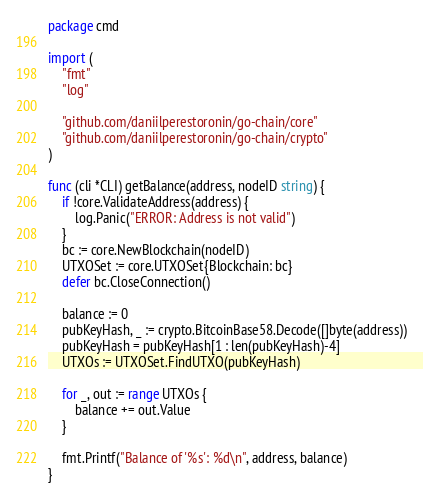Convert code to text. <code><loc_0><loc_0><loc_500><loc_500><_Go_>package cmd

import (
	"fmt"
	"log"

	"github.com/daniilperestoronin/go-chain/core"
	"github.com/daniilperestoronin/go-chain/crypto"
)

func (cli *CLI) getBalance(address, nodeID string) {
	if !core.ValidateAddress(address) {
		log.Panic("ERROR: Address is not valid")
	}
	bc := core.NewBlockchain(nodeID)
	UTXOSet := core.UTXOSet{Blockchain: bc}
	defer bc.CloseConnection()

	balance := 0
	pubKeyHash, _ := crypto.BitcoinBase58.Decode([]byte(address))
	pubKeyHash = pubKeyHash[1 : len(pubKeyHash)-4]
	UTXOs := UTXOSet.FindUTXO(pubKeyHash)

	for _, out := range UTXOs {
		balance += out.Value
	}

	fmt.Printf("Balance of '%s': %d\n", address, balance)
}
</code> 